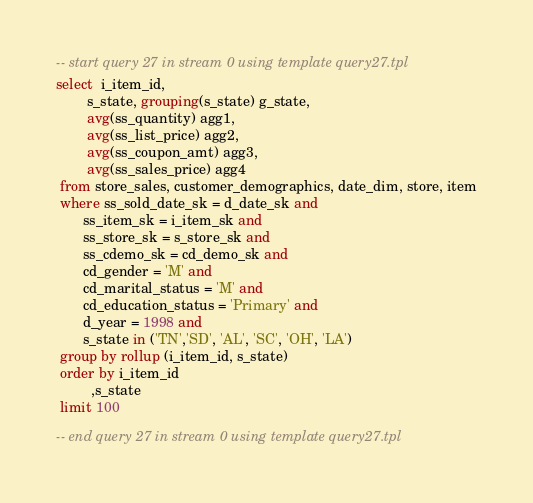<code> <loc_0><loc_0><loc_500><loc_500><_SQL_>-- start query 27 in stream 0 using template query27.tpl
select  i_item_id,
        s_state, grouping(s_state) g_state,
        avg(ss_quantity) agg1,
        avg(ss_list_price) agg2,
        avg(ss_coupon_amt) agg3,
        avg(ss_sales_price) agg4
 from store_sales, customer_demographics, date_dim, store, item
 where ss_sold_date_sk = d_date_sk and
       ss_item_sk = i_item_sk and
       ss_store_sk = s_store_sk and
       ss_cdemo_sk = cd_demo_sk and
       cd_gender = 'M' and
       cd_marital_status = 'M' and
       cd_education_status = 'Primary' and
       d_year = 1998 and
       s_state in ('TN','SD', 'AL', 'SC', 'OH', 'LA')
 group by rollup (i_item_id, s_state)
 order by i_item_id
         ,s_state
 limit 100

-- end query 27 in stream 0 using template query27.tpl
</code> 